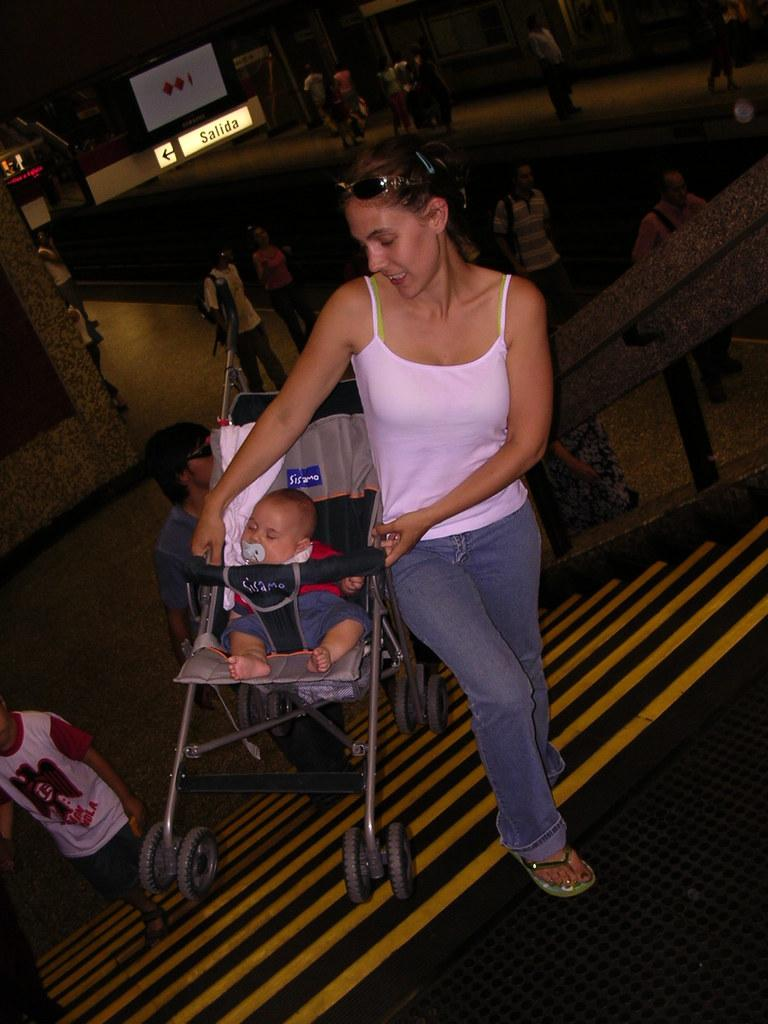<image>
Offer a succinct explanation of the picture presented. A baby sits in a stroller which reads Sisamo. 